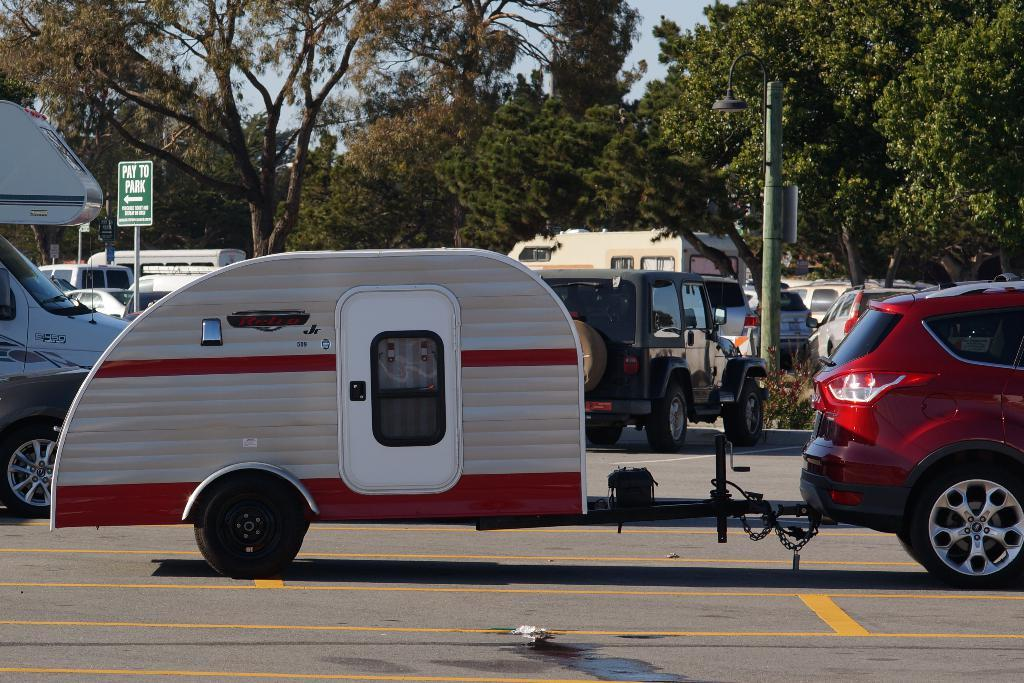<image>
Give a short and clear explanation of the subsequent image. A gree sign has an arrow pointing to the left that says to pay to park. 